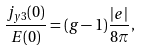<formula> <loc_0><loc_0><loc_500><loc_500>\frac { j _ { y 3 } ( 0 ) } { E ( 0 ) } = ( g - 1 ) \frac { \left | e \right | } { 8 \pi } ,</formula> 